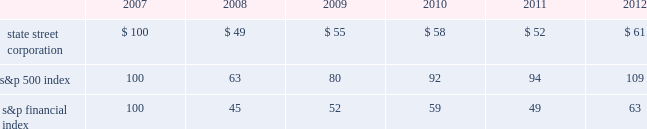Shareholder return performance presentation the graph presented below compares the cumulative total shareholder return on state street's common stock to the cumulative total return of the s&p 500 index and the s&p financial index over a five-year period .
The cumulative total shareholder return assumes the investment of $ 100 in state street common stock and in each index on december 31 , 2007 at the closing price on the last trading day of 2007 , and also assumes reinvestment of common stock dividends .
The s&p financial index is a publicly available measure of 80 of the standard & poor's 500 companies , representing 26 diversified financial services companies , 22 insurance companies , 17 real estate companies and 15 banking companies .
Comparison of five-year cumulative total shareholder return .

What is the roi of an investment in state street corporation from 2007 to 2009? 
Computations: ((55 - 100) / 100)
Answer: -0.45. 